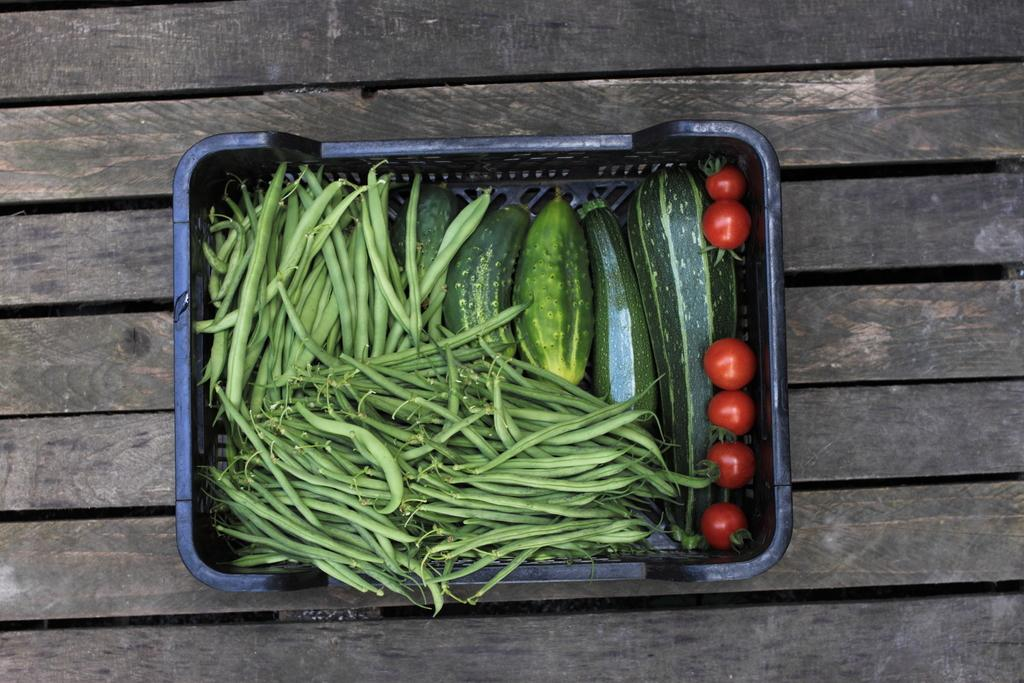What is the main object in the center of the image? There is a wooden object in the center of the image. What is placed on the wooden object? There is a basket on the wooden object. What is inside the basket? The basket contains vegetables. Can you describe the beetle crawling on the vegetables in the basket? There is no beetle present in the image; the basket contains only vegetables. 